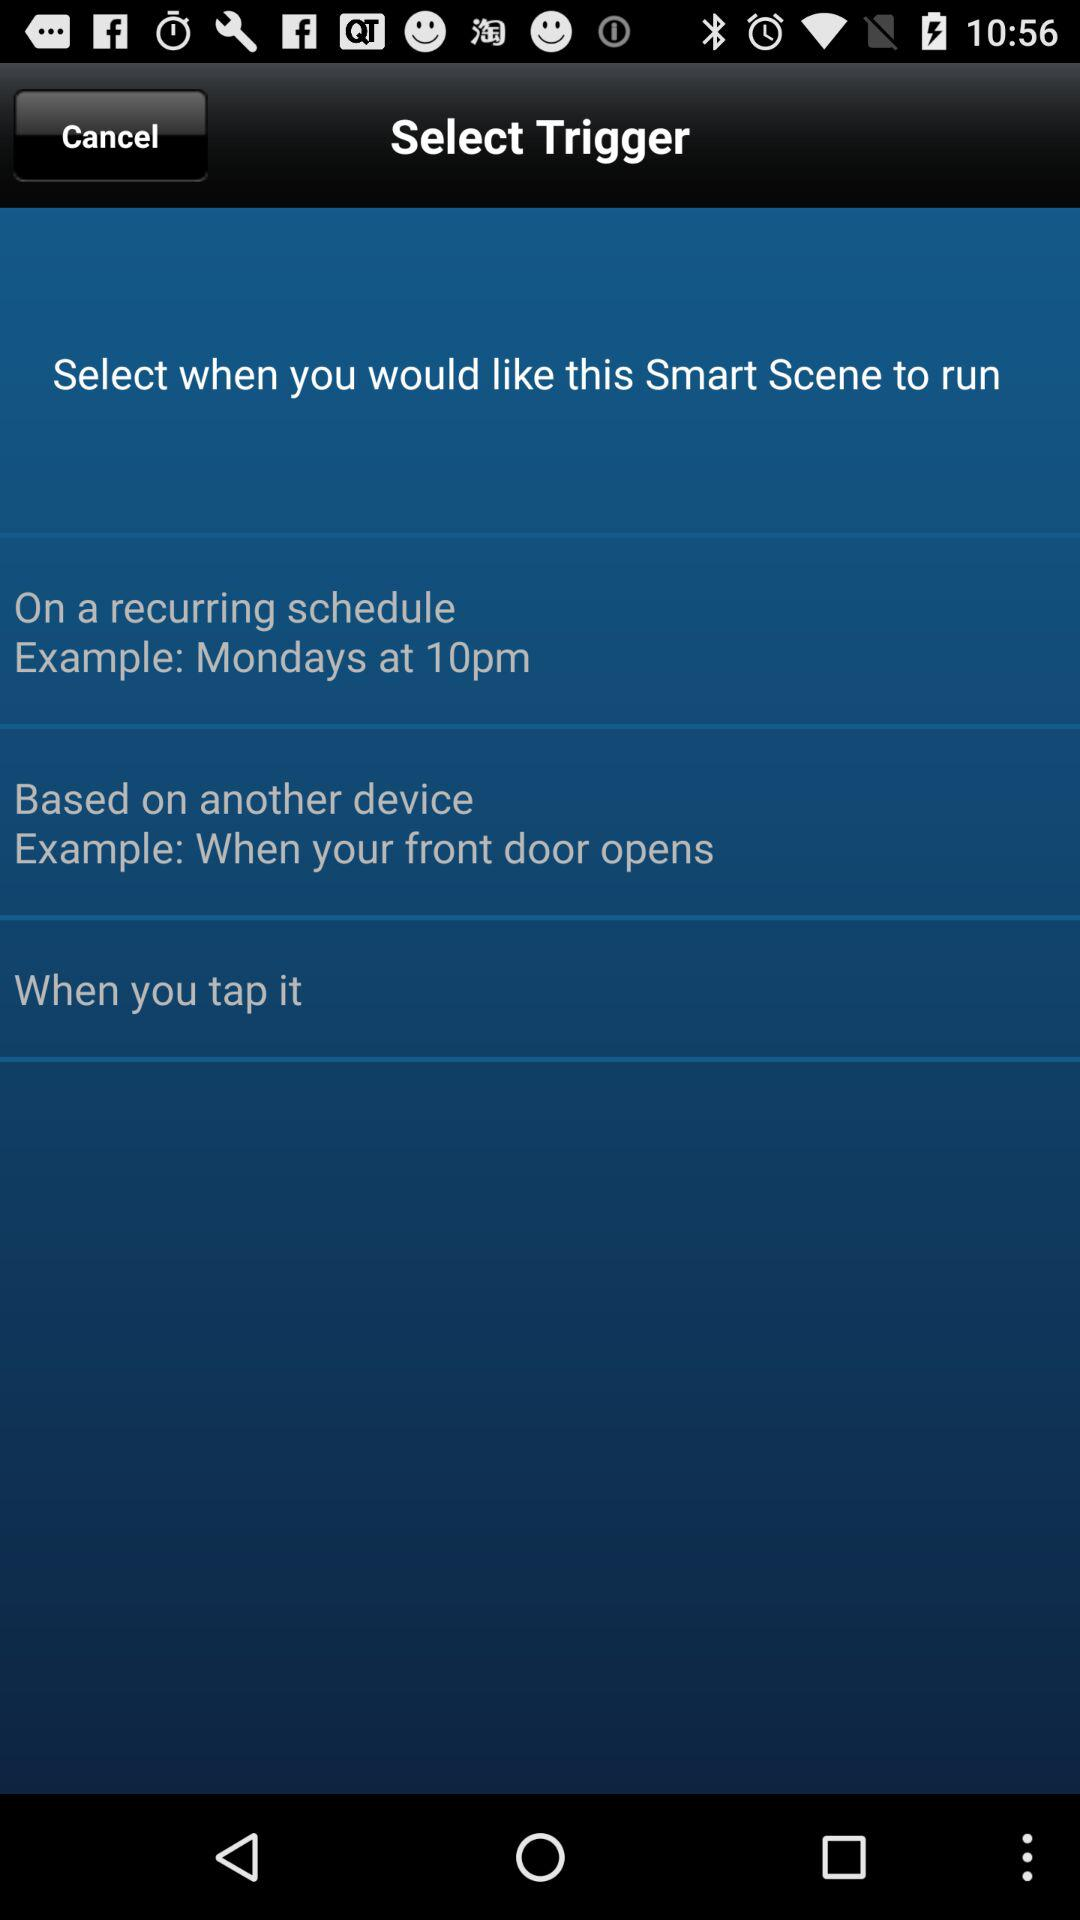What is the scheduled time for Monday? The scheduled time for Monday is 10 p.m. 